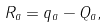<formula> <loc_0><loc_0><loc_500><loc_500>R _ { a } = q _ { a } - Q _ { a } ,</formula> 